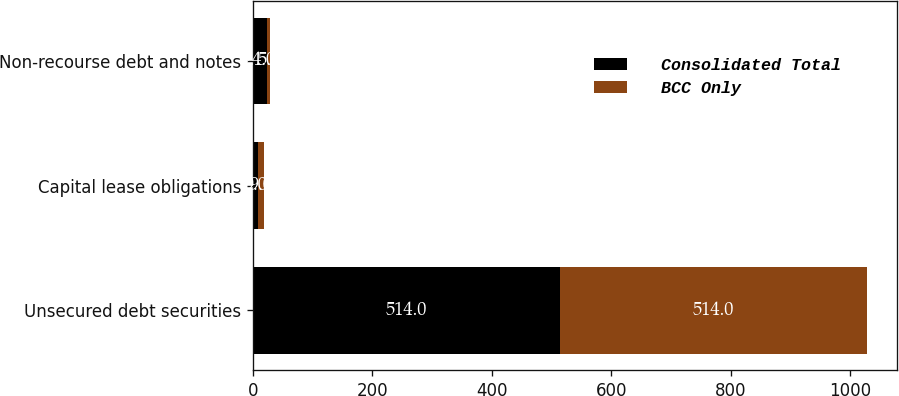Convert chart. <chart><loc_0><loc_0><loc_500><loc_500><stacked_bar_chart><ecel><fcel>Unsecured debt securities<fcel>Capital lease obligations<fcel>Non-recourse debt and notes<nl><fcel>Consolidated Total<fcel>514<fcel>9<fcel>24<nl><fcel>BCC Only<fcel>514<fcel>9<fcel>5<nl></chart> 